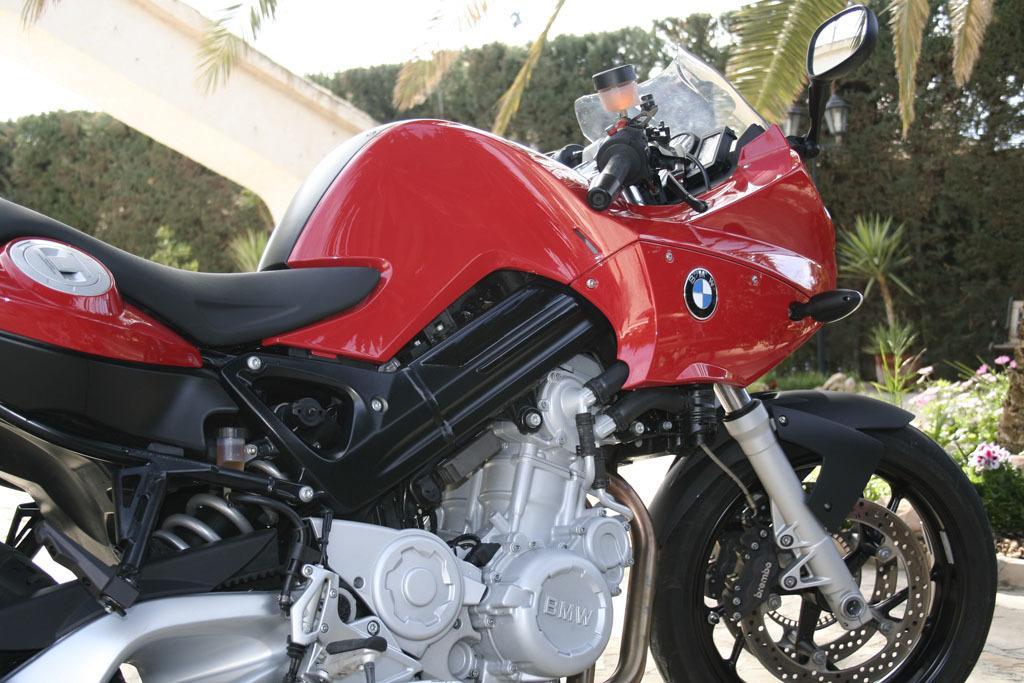How would you summarize this image in a sentence or two? In this picture we can see red color sports bike seen in the image. Behind we can some coconut trees and plants in the pot. 